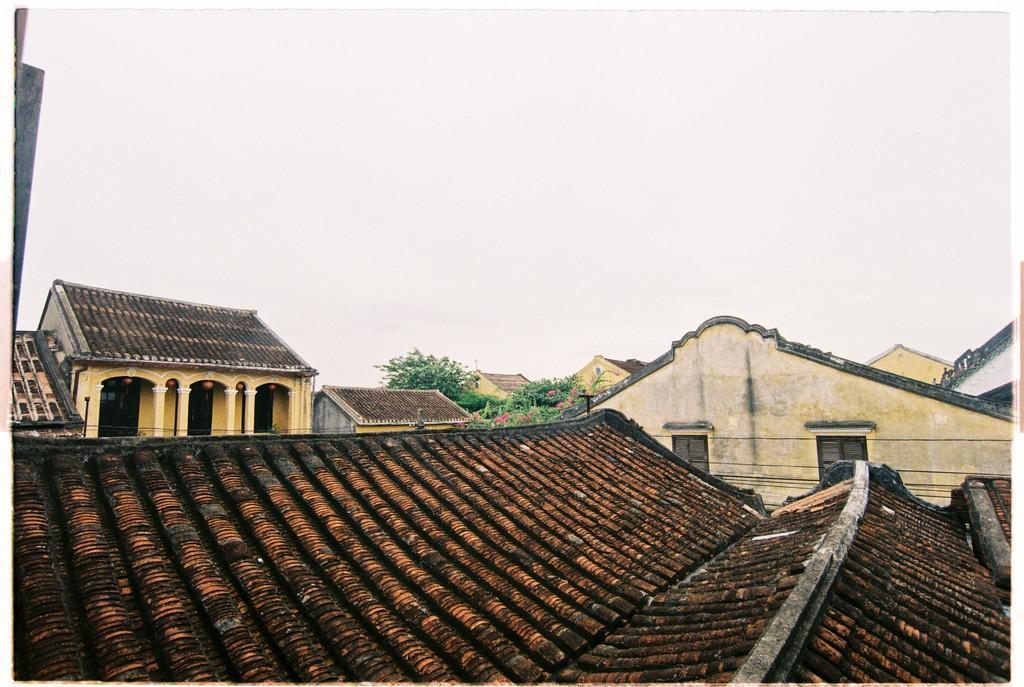Could you give a brief overview of what you see in this image? This is the picture of the view of a place where we have some houses to which there are some brown and maroon color roofs, there are some some windows to the houses. 